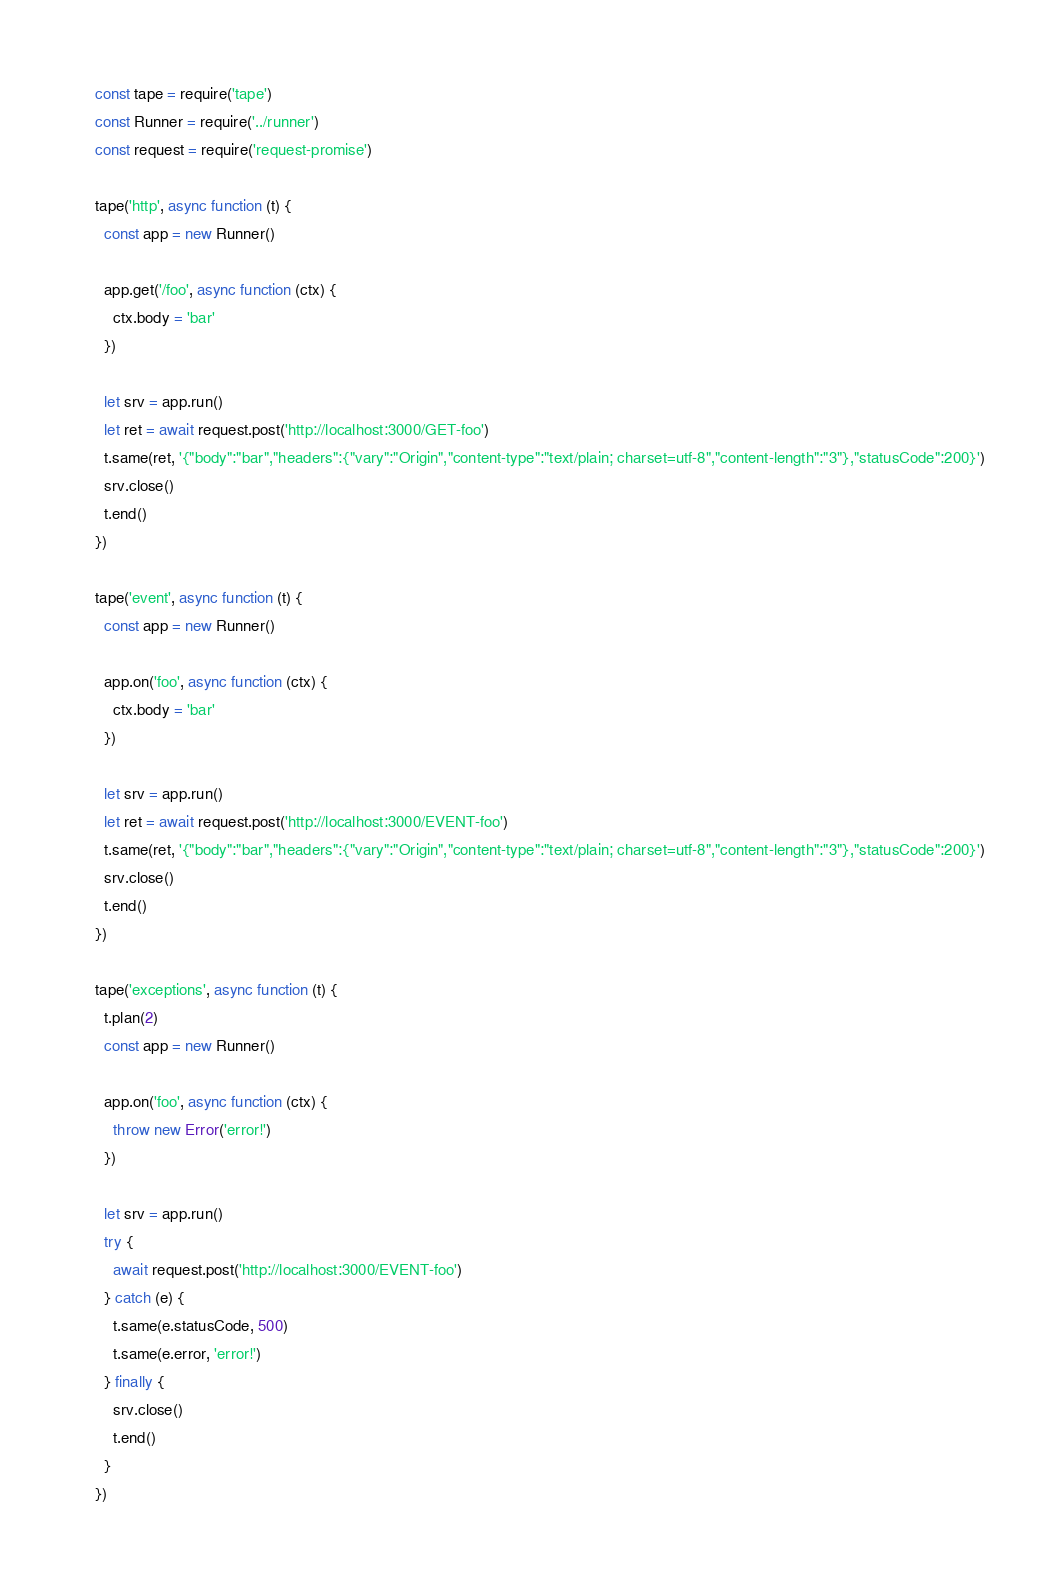Convert code to text. <code><loc_0><loc_0><loc_500><loc_500><_JavaScript_>const tape = require('tape')
const Runner = require('../runner')
const request = require('request-promise')

tape('http', async function (t) {
  const app = new Runner()

  app.get('/foo', async function (ctx) {
    ctx.body = 'bar'
  })

  let srv = app.run()
  let ret = await request.post('http://localhost:3000/GET-foo')
  t.same(ret, '{"body":"bar","headers":{"vary":"Origin","content-type":"text/plain; charset=utf-8","content-length":"3"},"statusCode":200}')
  srv.close()
  t.end()
})

tape('event', async function (t) {
  const app = new Runner()

  app.on('foo', async function (ctx) {
    ctx.body = 'bar'
  })

  let srv = app.run()
  let ret = await request.post('http://localhost:3000/EVENT-foo')
  t.same(ret, '{"body":"bar","headers":{"vary":"Origin","content-type":"text/plain; charset=utf-8","content-length":"3"},"statusCode":200}')
  srv.close()
  t.end()
})

tape('exceptions', async function (t) {
  t.plan(2)
  const app = new Runner()

  app.on('foo', async function (ctx) {
    throw new Error('error!')
  })

  let srv = app.run()
  try {
    await request.post('http://localhost:3000/EVENT-foo')
  } catch (e) {
    t.same(e.statusCode, 500)
    t.same(e.error, 'error!')
  } finally {
    srv.close()
    t.end()
  }
})
</code> 